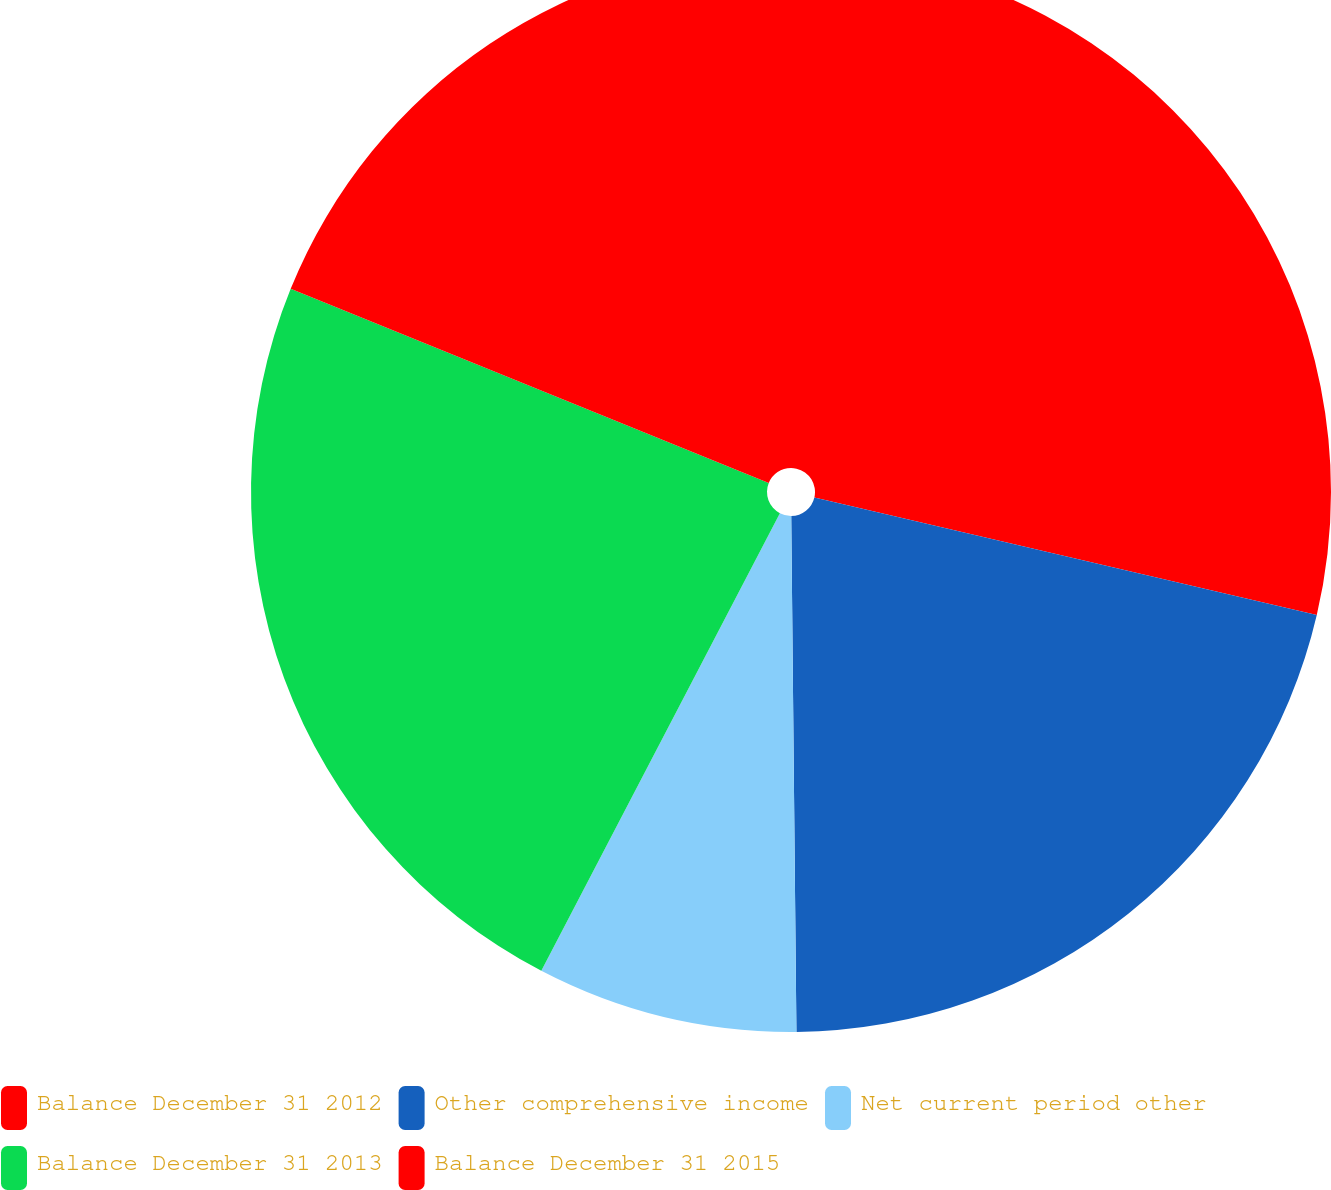Convert chart. <chart><loc_0><loc_0><loc_500><loc_500><pie_chart><fcel>Balance December 31 2012<fcel>Other comprehensive income<fcel>Net current period other<fcel>Balance December 31 2013<fcel>Balance December 31 2015<nl><fcel>28.66%<fcel>21.18%<fcel>7.81%<fcel>23.49%<fcel>18.86%<nl></chart> 